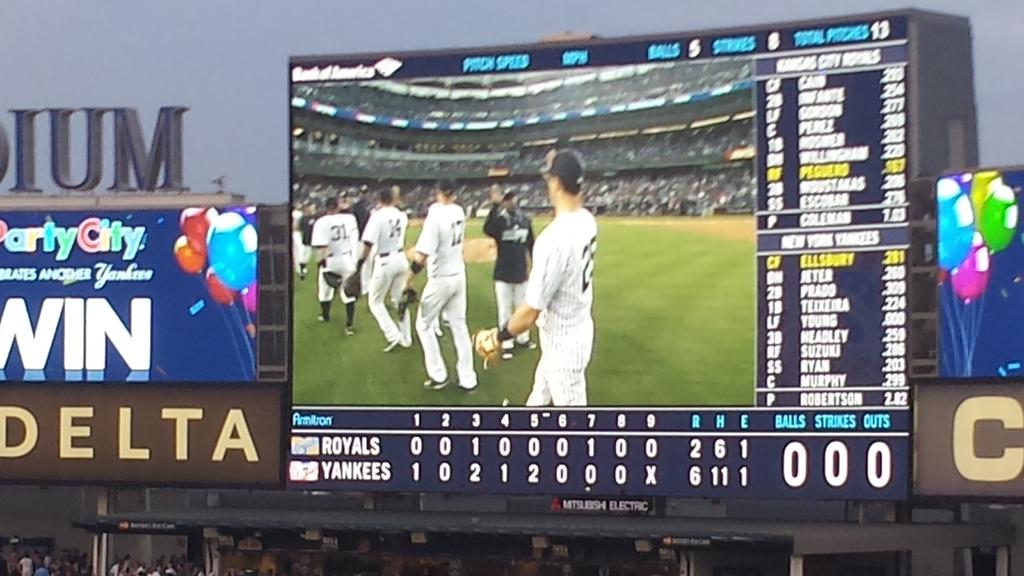Who is playing?
Offer a terse response. Royals and yankees. 